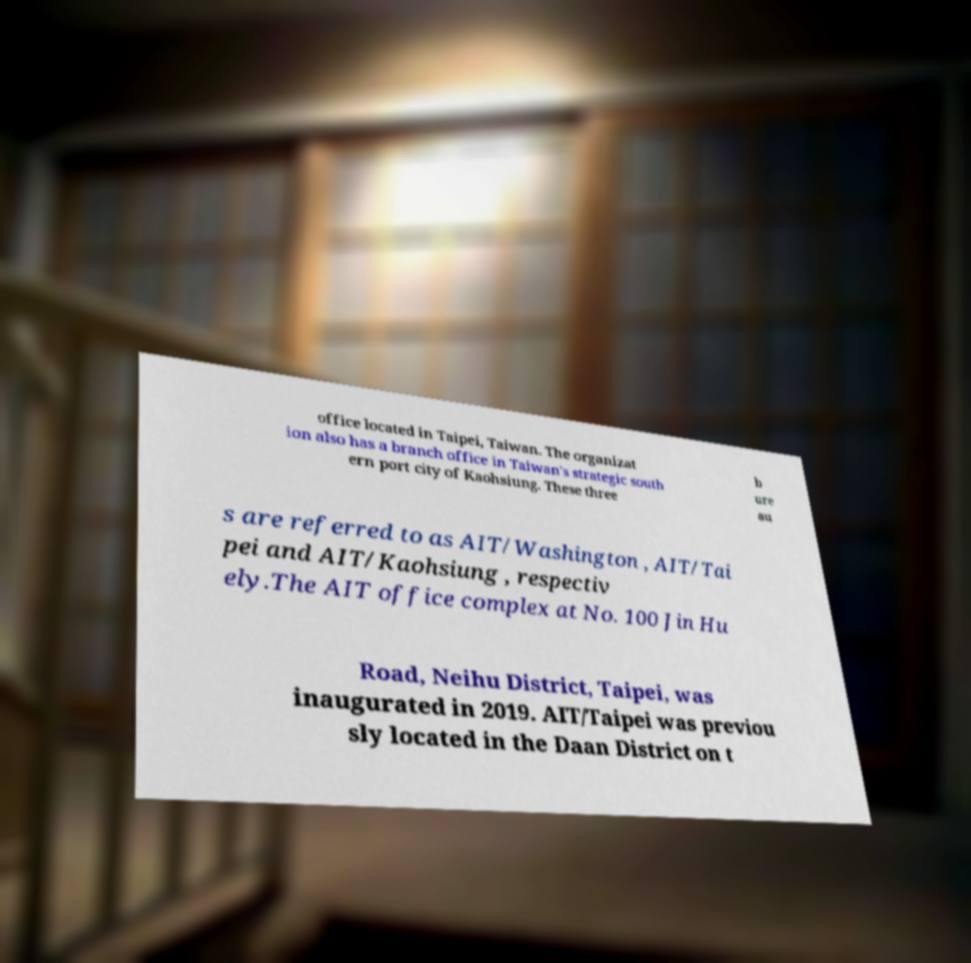Please identify and transcribe the text found in this image. office located in Taipei, Taiwan. The organizat ion also has a branch office in Taiwan's strategic south ern port city of Kaohsiung. These three b ure au s are referred to as AIT/Washington , AIT/Tai pei and AIT/Kaohsiung , respectiv ely.The AIT office complex at No. 100 Jin Hu Road, Neihu District, Taipei, was inaugurated in 2019. AIT/Taipei was previou sly located in the Daan District on t 